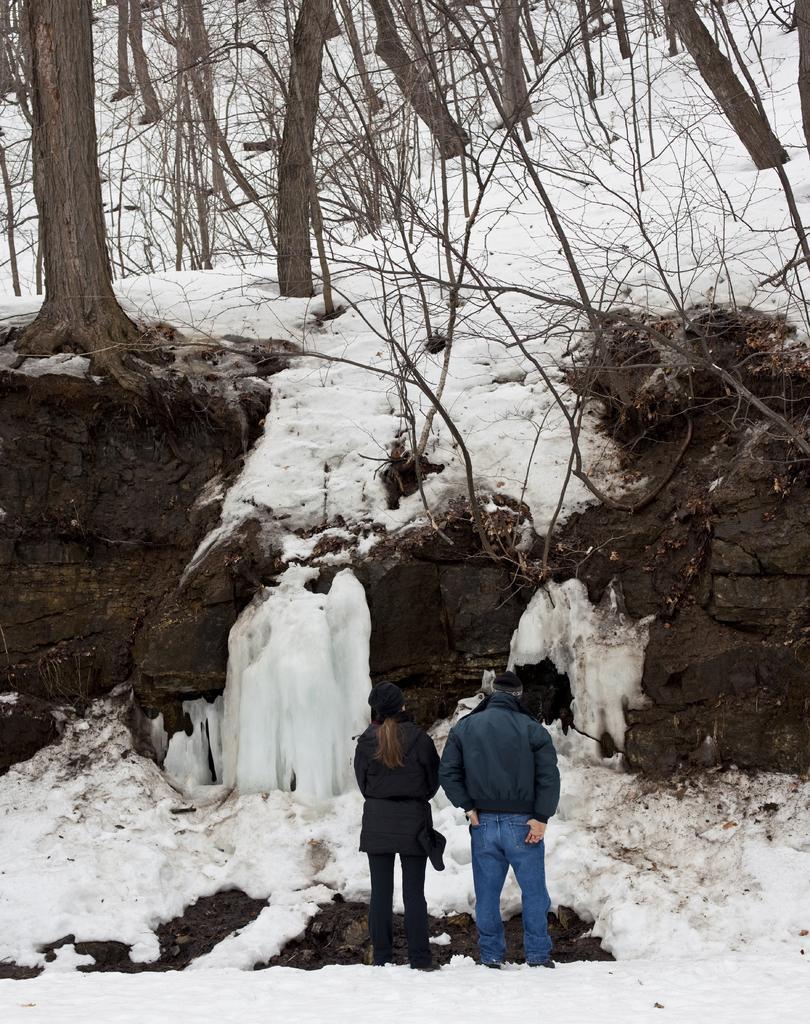How would you summarize this image in a sentence or two? In this image I can see two people are standing and I can see both of them are wearing jackets and caps. I can also see snow on ground and number of trees. 